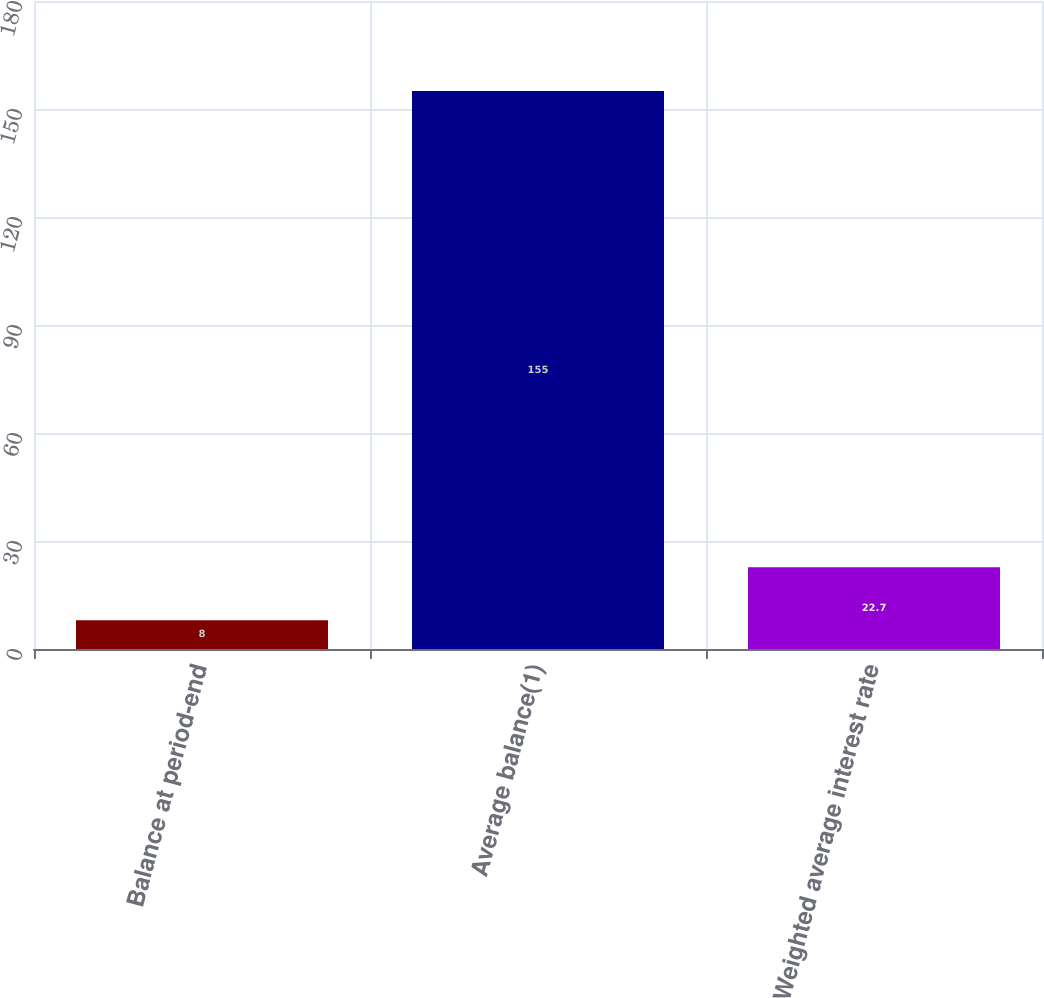Convert chart to OTSL. <chart><loc_0><loc_0><loc_500><loc_500><bar_chart><fcel>Balance at period-end<fcel>Average balance(1)<fcel>Weighted average interest rate<nl><fcel>8<fcel>155<fcel>22.7<nl></chart> 